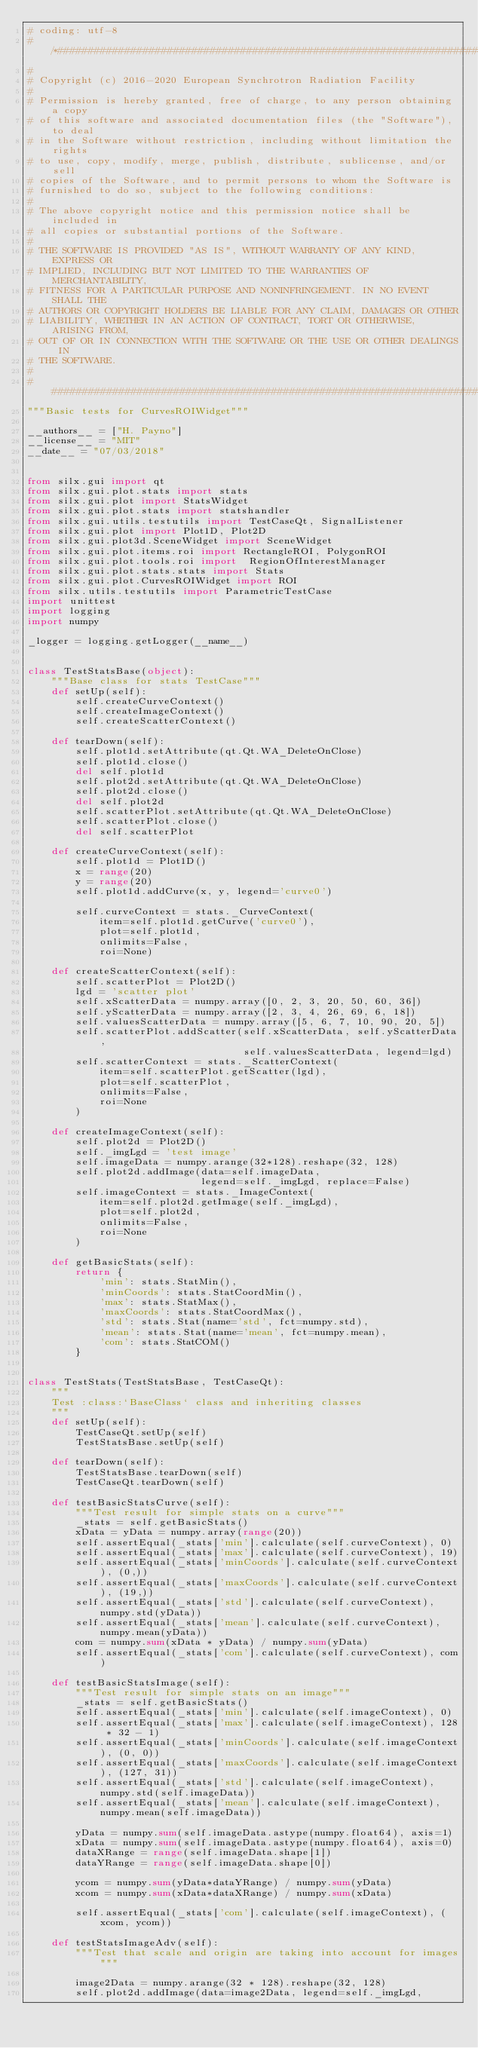Convert code to text. <code><loc_0><loc_0><loc_500><loc_500><_Python_># coding: utf-8
# /*##########################################################################
#
# Copyright (c) 2016-2020 European Synchrotron Radiation Facility
#
# Permission is hereby granted, free of charge, to any person obtaining a copy
# of this software and associated documentation files (the "Software"), to deal
# in the Software without restriction, including without limitation the rights
# to use, copy, modify, merge, publish, distribute, sublicense, and/or sell
# copies of the Software, and to permit persons to whom the Software is
# furnished to do so, subject to the following conditions:
#
# The above copyright notice and this permission notice shall be included in
# all copies or substantial portions of the Software.
#
# THE SOFTWARE IS PROVIDED "AS IS", WITHOUT WARRANTY OF ANY KIND, EXPRESS OR
# IMPLIED, INCLUDING BUT NOT LIMITED TO THE WARRANTIES OF MERCHANTABILITY,
# FITNESS FOR A PARTICULAR PURPOSE AND NONINFRINGEMENT. IN NO EVENT SHALL THE
# AUTHORS OR COPYRIGHT HOLDERS BE LIABLE FOR ANY CLAIM, DAMAGES OR OTHER
# LIABILITY, WHETHER IN AN ACTION OF CONTRACT, TORT OR OTHERWISE, ARISING FROM,
# OUT OF OR IN CONNECTION WITH THE SOFTWARE OR THE USE OR OTHER DEALINGS IN
# THE SOFTWARE.
#
# ###########################################################################*/
"""Basic tests for CurvesROIWidget"""

__authors__ = ["H. Payno"]
__license__ = "MIT"
__date__ = "07/03/2018"


from silx.gui import qt
from silx.gui.plot.stats import stats
from silx.gui.plot import StatsWidget
from silx.gui.plot.stats import statshandler
from silx.gui.utils.testutils import TestCaseQt, SignalListener
from silx.gui.plot import Plot1D, Plot2D
from silx.gui.plot3d.SceneWidget import SceneWidget
from silx.gui.plot.items.roi import RectangleROI, PolygonROI
from silx.gui.plot.tools.roi import  RegionOfInterestManager
from silx.gui.plot.stats.stats import Stats
from silx.gui.plot.CurvesROIWidget import ROI
from silx.utils.testutils import ParametricTestCase
import unittest
import logging
import numpy

_logger = logging.getLogger(__name__)


class TestStatsBase(object):
    """Base class for stats TestCase"""
    def setUp(self):
        self.createCurveContext()
        self.createImageContext()
        self.createScatterContext()

    def tearDown(self):
        self.plot1d.setAttribute(qt.Qt.WA_DeleteOnClose)
        self.plot1d.close()
        del self.plot1d
        self.plot2d.setAttribute(qt.Qt.WA_DeleteOnClose)
        self.plot2d.close()
        del self.plot2d
        self.scatterPlot.setAttribute(qt.Qt.WA_DeleteOnClose)
        self.scatterPlot.close()
        del self.scatterPlot

    def createCurveContext(self):
        self.plot1d = Plot1D()
        x = range(20)
        y = range(20)
        self.plot1d.addCurve(x, y, legend='curve0')

        self.curveContext = stats._CurveContext(
            item=self.plot1d.getCurve('curve0'),
            plot=self.plot1d,
            onlimits=False,
            roi=None)

    def createScatterContext(self):
        self.scatterPlot = Plot2D()
        lgd = 'scatter plot'
        self.xScatterData = numpy.array([0, 2, 3, 20, 50, 60, 36])
        self.yScatterData = numpy.array([2, 3, 4, 26, 69, 6, 18])
        self.valuesScatterData = numpy.array([5, 6, 7, 10, 90, 20, 5])
        self.scatterPlot.addScatter(self.xScatterData, self.yScatterData,
                                    self.valuesScatterData, legend=lgd)
        self.scatterContext = stats._ScatterContext(
            item=self.scatterPlot.getScatter(lgd),
            plot=self.scatterPlot,
            onlimits=False,
            roi=None
        )

    def createImageContext(self):
        self.plot2d = Plot2D()
        self._imgLgd = 'test image'
        self.imageData = numpy.arange(32*128).reshape(32, 128)
        self.plot2d.addImage(data=self.imageData,
                             legend=self._imgLgd, replace=False)
        self.imageContext = stats._ImageContext(
            item=self.plot2d.getImage(self._imgLgd),
            plot=self.plot2d,
            onlimits=False,
            roi=None
        )

    def getBasicStats(self):
        return {
            'min': stats.StatMin(),
            'minCoords': stats.StatCoordMin(),
            'max': stats.StatMax(),
            'maxCoords': stats.StatCoordMax(),
            'std': stats.Stat(name='std', fct=numpy.std),
            'mean': stats.Stat(name='mean', fct=numpy.mean),
            'com': stats.StatCOM()
        }


class TestStats(TestStatsBase, TestCaseQt):
    """
    Test :class:`BaseClass` class and inheriting classes
    """
    def setUp(self):
        TestCaseQt.setUp(self)
        TestStatsBase.setUp(self)

    def tearDown(self):
        TestStatsBase.tearDown(self)
        TestCaseQt.tearDown(self)

    def testBasicStatsCurve(self):
        """Test result for simple stats on a curve"""
        _stats = self.getBasicStats()
        xData = yData = numpy.array(range(20))
        self.assertEqual(_stats['min'].calculate(self.curveContext), 0)
        self.assertEqual(_stats['max'].calculate(self.curveContext), 19)
        self.assertEqual(_stats['minCoords'].calculate(self.curveContext), (0,))
        self.assertEqual(_stats['maxCoords'].calculate(self.curveContext), (19,))
        self.assertEqual(_stats['std'].calculate(self.curveContext), numpy.std(yData))
        self.assertEqual(_stats['mean'].calculate(self.curveContext), numpy.mean(yData))
        com = numpy.sum(xData * yData) / numpy.sum(yData)
        self.assertEqual(_stats['com'].calculate(self.curveContext), com)

    def testBasicStatsImage(self):
        """Test result for simple stats on an image"""
        _stats = self.getBasicStats()
        self.assertEqual(_stats['min'].calculate(self.imageContext), 0)
        self.assertEqual(_stats['max'].calculate(self.imageContext), 128 * 32 - 1)
        self.assertEqual(_stats['minCoords'].calculate(self.imageContext), (0, 0))
        self.assertEqual(_stats['maxCoords'].calculate(self.imageContext), (127, 31))
        self.assertEqual(_stats['std'].calculate(self.imageContext), numpy.std(self.imageData))
        self.assertEqual(_stats['mean'].calculate(self.imageContext), numpy.mean(self.imageData))

        yData = numpy.sum(self.imageData.astype(numpy.float64), axis=1)
        xData = numpy.sum(self.imageData.astype(numpy.float64), axis=0)
        dataXRange = range(self.imageData.shape[1])
        dataYRange = range(self.imageData.shape[0])

        ycom = numpy.sum(yData*dataYRange) / numpy.sum(yData)
        xcom = numpy.sum(xData*dataXRange) / numpy.sum(xData)

        self.assertEqual(_stats['com'].calculate(self.imageContext), (xcom, ycom))

    def testStatsImageAdv(self):
        """Test that scale and origin are taking into account for images"""

        image2Data = numpy.arange(32 * 128).reshape(32, 128)
        self.plot2d.addImage(data=image2Data, legend=self._imgLgd,</code> 